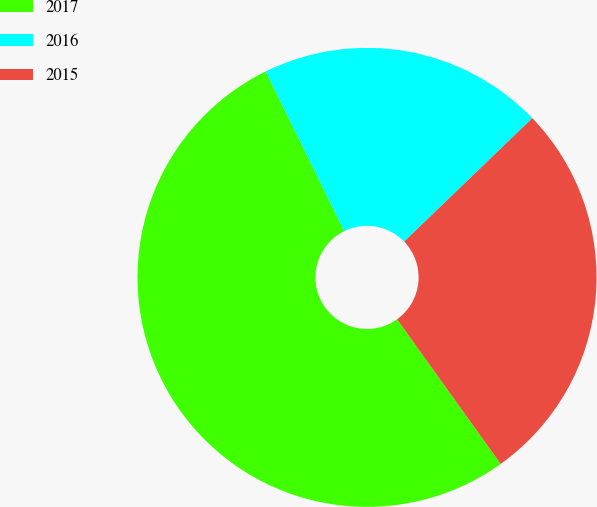Convert chart. <chart><loc_0><loc_0><loc_500><loc_500><pie_chart><fcel>2017<fcel>2016<fcel>2015<nl><fcel>52.61%<fcel>20.08%<fcel>27.31%<nl></chart> 